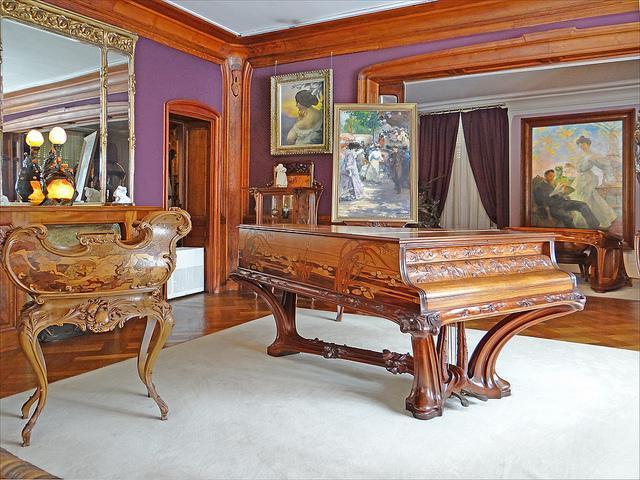How many cats are on the second shelf from the top?
Give a very brief answer. 0. 